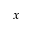<formula> <loc_0><loc_0><loc_500><loc_500>x</formula> 